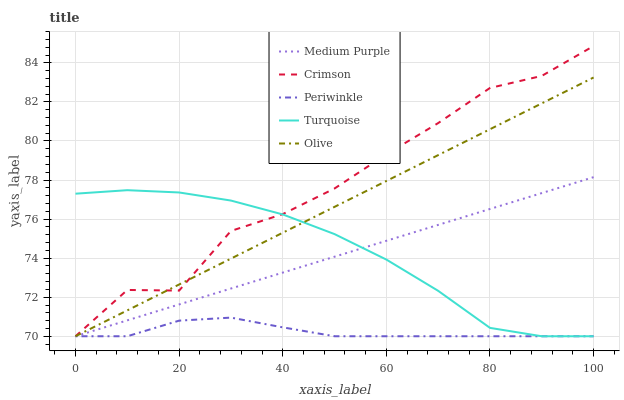Does Periwinkle have the minimum area under the curve?
Answer yes or no. Yes. Does Turquoise have the minimum area under the curve?
Answer yes or no. No. Does Turquoise have the maximum area under the curve?
Answer yes or no. No. Is Turquoise the smoothest?
Answer yes or no. No. Is Turquoise the roughest?
Answer yes or no. No. Does Turquoise have the highest value?
Answer yes or no. No. 